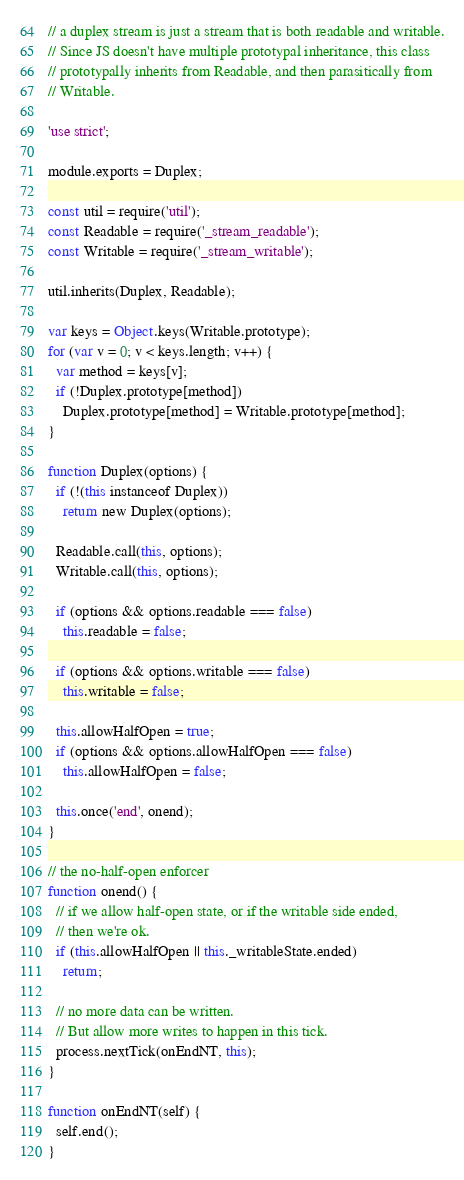<code> <loc_0><loc_0><loc_500><loc_500><_JavaScript_>// a duplex stream is just a stream that is both readable and writable.
// Since JS doesn't have multiple prototypal inheritance, this class
// prototypally inherits from Readable, and then parasitically from
// Writable.

'use strict';

module.exports = Duplex;

const util = require('util');
const Readable = require('_stream_readable');
const Writable = require('_stream_writable');

util.inherits(Duplex, Readable);

var keys = Object.keys(Writable.prototype);
for (var v = 0; v < keys.length; v++) {
  var method = keys[v];
  if (!Duplex.prototype[method])
    Duplex.prototype[method] = Writable.prototype[method];
}

function Duplex(options) {
  if (!(this instanceof Duplex))
    return new Duplex(options);

  Readable.call(this, options);
  Writable.call(this, options);

  if (options && options.readable === false)
    this.readable = false;

  if (options && options.writable === false)
    this.writable = false;

  this.allowHalfOpen = true;
  if (options && options.allowHalfOpen === false)
    this.allowHalfOpen = false;

  this.once('end', onend);
}

// the no-half-open enforcer
function onend() {
  // if we allow half-open state, or if the writable side ended,
  // then we're ok.
  if (this.allowHalfOpen || this._writableState.ended)
    return;

  // no more data can be written.
  // But allow more writes to happen in this tick.
  process.nextTick(onEndNT, this);
}

function onEndNT(self) {
  self.end();
}
</code> 